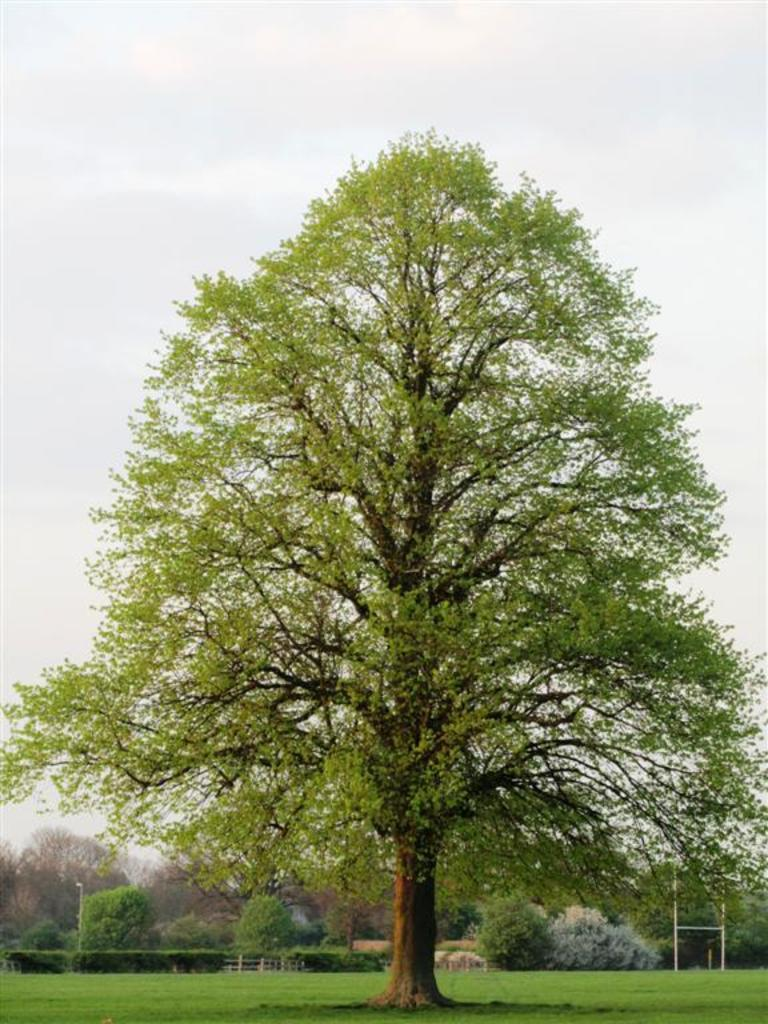What is located in the foreground of the image? There is a tree in the foreground of the image. What can be seen in the background of the image? There are trees visible in the background of the image. What other objects are present in the image? There are poles in the image. What is visible at the top of the image? The sky is visible at the top of the image. What type of ground is present in the image? Grass is present at the bottom of the image. What type of hospital can be seen in the background of the image? There is no hospital present in the image; it features a tree in the foreground, trees in the background, poles, the sky, and grass. What force is being applied to the doll in the image? There is no doll present in the image, so no force can be applied to it. 